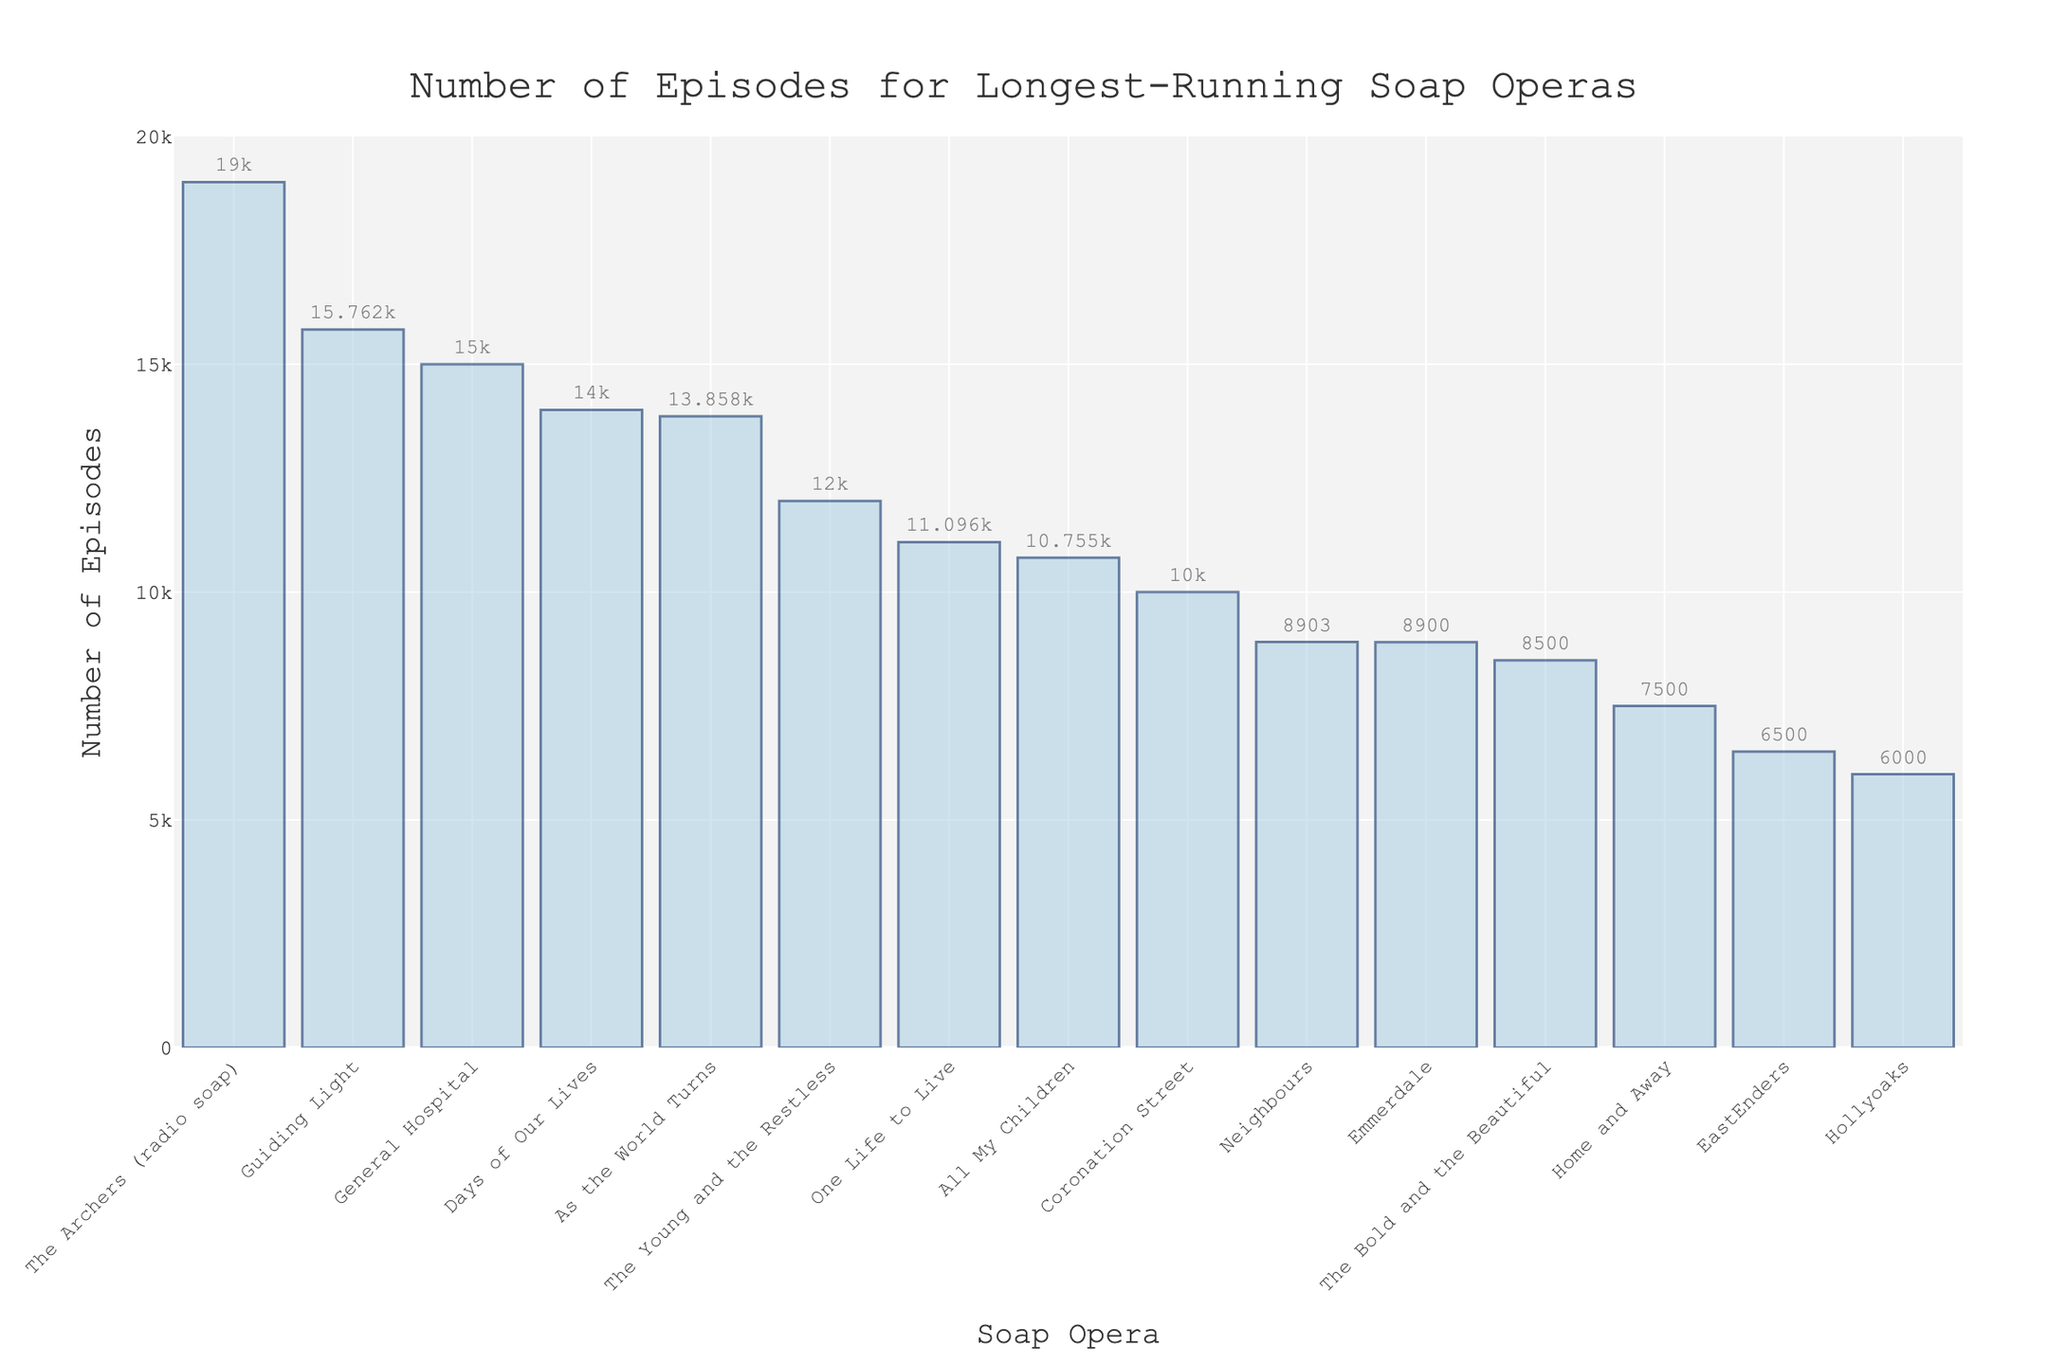what is the highest number of episodes for any soap opera? The tallest bar in the chart represents the soap opera with the most episodes. By looking at the height of each bar, we can see that "The Archers (radio soap)" has the highest number of episodes at 19,000.
Answer: 19,000 which soap operas have more than 15,000 episodes aired? Look at the bars and their corresponding labels to identify soap operas with episodes greater than 15,000. "Guiding Light" and "The Archers (radio soap)" exceed 15,000 episodes.
Answer: Guiding Light, The Archers (radio soap) how many more episodes does "Guiding Light" have compared to "All My Children"? Identify the number of episodes for both soap operas and subtract the smaller amount from the larger. "Guiding Light" has 15,762 episodes, and "All My Children" has 10,755 episodes. So, 15,762 - 10,755 = 5,007.
Answer: 5,007 how many soap operas have fewer than 7,000 episodes aired? Count the bars representing soap operas with fewer than 7,000 episodes. "EastEnders," "Hollyoaks," and "Home and Away" are the ones meeting this criterion, totaling 3.
Answer: 3 what is the average number of episodes for "The Young and the Restless," "Coronation Street," and "One Life to Live"? Sum the episodes for each soap opera and divide by the number of soap operas. (12,000 + 10,000 + 11,096) / 3 = 11,032.
Answer: 11,032 which soap opera has the shortest bar in the chart? The soap opera with the shortest bar is the one with the least number of episodes. "Hollyoaks" with 6,000 episodes has the shortest bar.
Answer: Hollyoaks is "General Hospital" aired more or fewer episodes than "Days of Our Lives"? Compare the bars of "General Hospital" and "Days of Our Lives." "General Hospital" has 15,000 episodes, while "Days of Our Lives" has 14,000 episodes. "General Hospital" has more.
Answer: more what are the total number of episodes for "EastEnders," "Emmerdale," and "Neighbours"? Sum the episodes for each soap opera. "EastEnders" (6,500), "Emmerdale" (8,900), and "Neighbours" (8,903): 6,500 + 8,900 + 8,903 = 24,303.
Answer: 24,303 which soap opera has a higher number of episodes: "All My Children" or "One Life to Live"? Compare the bars representing "All My Children" and "One Life to Live." "One Life to Live" has 11,096 episodes, while "All My Children" has 10,755. "One Life to Live" has more episodes.
Answer: One Life to Live what is the total number of episodes for the soap operas with more than 10,000 episodes? Sum the episodes of soap operas with more than 10,000 episodes: "Guiding Light" (15,762), "As the World Turns" (13,858), "General Hospital" (15,000), "Days of Our Lives" (14,000), "One Life to Live" (11,096), "All My Children" (10,755), "The Young and the Restless" (12,000), "The Archers (radio soap)" (19,000), "Coronation Street" (10,000). The total is 120,471.
Answer: 120,471 